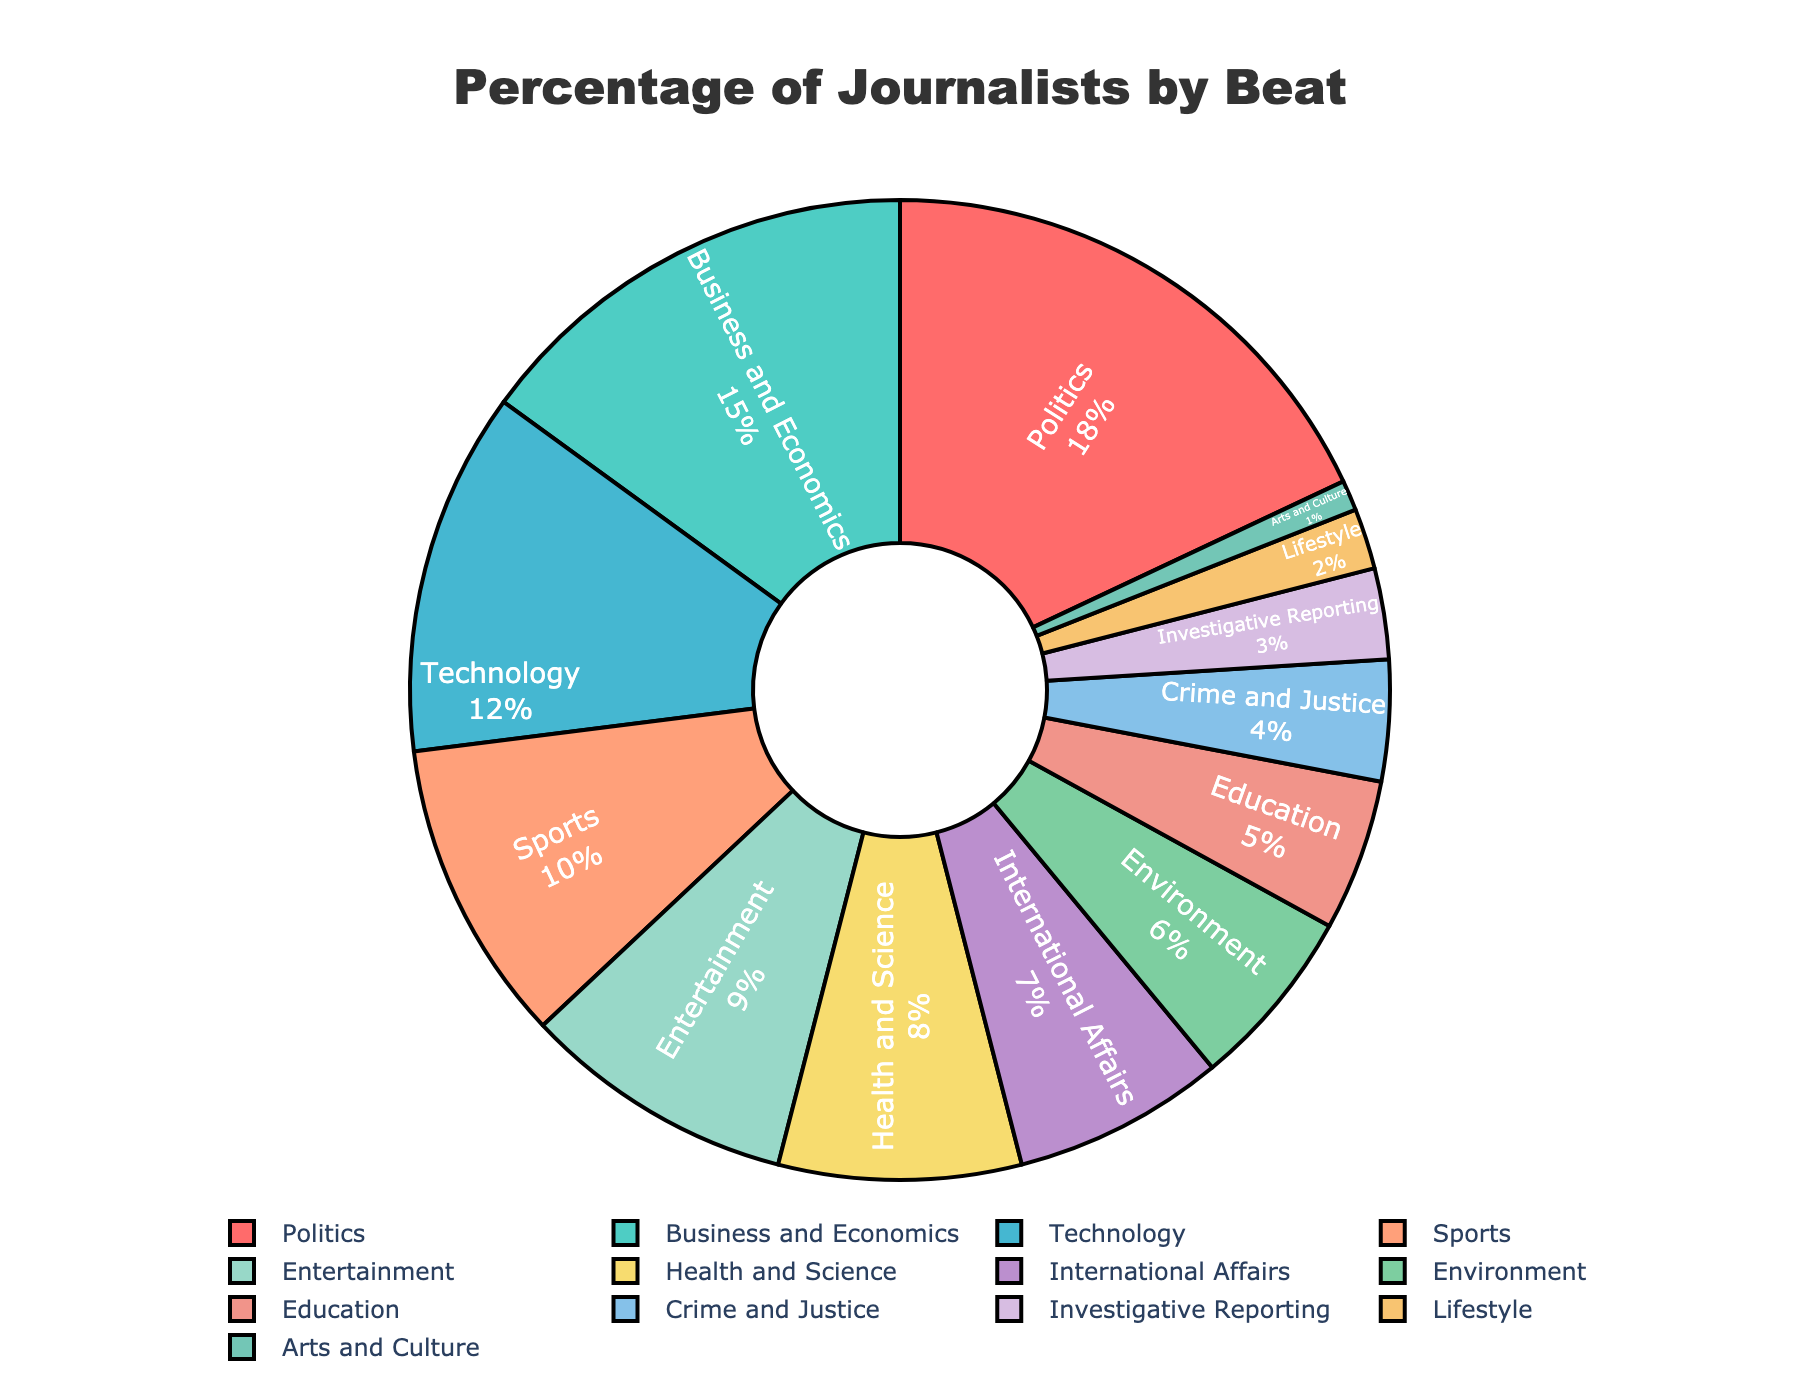What beat has the highest percentage of journalists? The figure shows that the "Politics" beat has the largest segment of the pie chart, indicating it has the highest percentage.
Answer: Politics Which two beats combined have a percentage equal to that of Politics? The "Politics" beat has 18%. By examining the data, we see that "Business and Economics" (15%) and "Arts and Culture" (1%) sum to 16%, which is close but not equal. "Technology" (12%) and "Health and Science" (8%) sum to 20%. Neither combination equals 18%. Therefore, "Business and Economics" and "Technology" (15% + 12% = 27%) don't match either but are closest in proportional representation.
Answer: Business and Economics and Technology (27%) What's the difference in percentage between the beats with the highest and lowest percent of journalists? The highest percentage beat is "Politics" at 18% and the lowest is "Arts and Culture" at 1%. Subtracting these gives: 18% - 1% = 17%.
Answer: 17% Which beats have percentages greater than Health and Science? The "Health and Science" beat has a percentage of 8%. Beats greater than this are "Politics" (18%), "Business and Economics" (15%), "Technology" (12%), "Sports" (10%), and "Entertainment" (9%).
Answer: Politics, Business and Economics, Technology, Sports, and Entertainment How many beats have a percentage less than 5%? According to the data: "Investigative Reporting" (3%), "Lifestyle" (2%), and "Arts and Culture" (1%) each have a percentage less than 5%. This totals 3 beats.
Answer: 3 Name three beats that collectively make up close to 20% of the total percentages. To get close to 20%, we can combine: "Health and Science" (8%), "Environment" (6%), and "Crime and Justice" (4%) yielding 8 + 6 + 4 = 18%. Another combination: "International Affairs" (7%), "Environment" (6%), and "Arts and Culture" (1%) yields 7 + 6 + 1 = 14%. From these, the nearest is: Health and Science, Environment, Crime and Justice.
Answer: Health and Science, Environment, and Crime and Justice What is the total percentage of journalists specializing in Entertainment, Sports, and Technology? By adding up the percentage of these three beats: Entertainment (9%), Sports (10%), and Technology (12%), we get 9 + 10 + 12 = 31%.
Answer: 31% Which beats are represented by green and blue colors? The colors representing specific segments of the pie chart are assigned visually as described: by examining the green and blue colors carefully - "Environment" (green, 6%) and both "Technology" (12%) and "Entertainment" (9%) appear in shades of blue.
Answer: Environment, Technology, Entertainment 